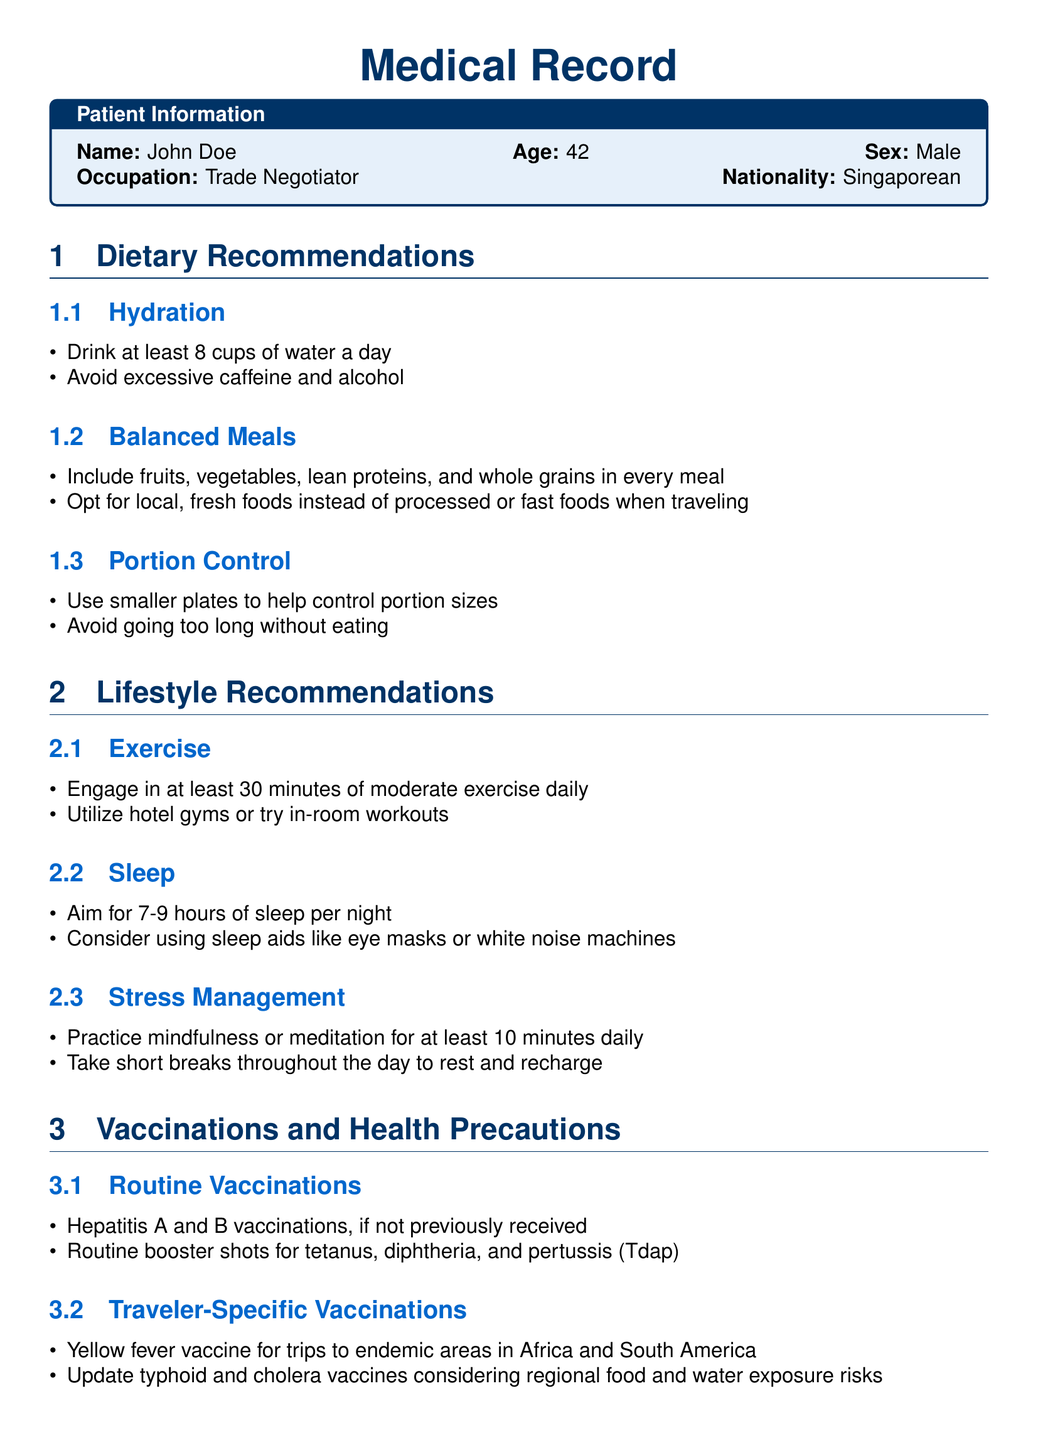What is the name of the patient? The patient's name is explicitly stated in the "Patient Information" section of the document.
Answer: John Doe How many cups of water should be consumed daily? The document specifies a hydration recommendation that indicates how many cups of water to drink per day.
Answer: 8 cups What type of vaccinations are recommended for travel to endemic areas? The document includes specific vaccinations related to travel, highlighting the importance for certain regions.
Answer: Yellow fever vaccine What is the recommended amount of sleep per night? The sleep section provides guidelines on how much sleep one should aim for nightly.
Answer: 7-9 hours What daily exercise duration is recommended? The exercise section mentions the minimum amount of moderate exercise advised for maintaining health.
Answer: 30 minutes Which food categories should be included in every meal? The balanced meals subsection lists various food categories that should be part of meals.
Answer: Fruits, vegetables, lean proteins, and whole grains What should be done to manage stress according to the document? The document provides a specific recommendation on a practice that aids in managing stress levels.
Answer: Practice mindfulness or meditation What is suggested for portion control? The portion control subsection suggests methods to help regulate portion sizes during meals.
Answer: Use smaller plates 